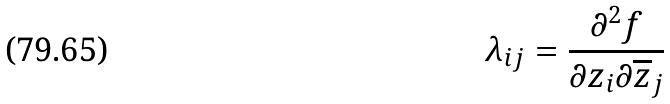<formula> <loc_0><loc_0><loc_500><loc_500>\lambda _ { i j } = \frac { \partial ^ { 2 } f } { \partial z _ { i } \partial \overline { z } _ { j } }</formula> 